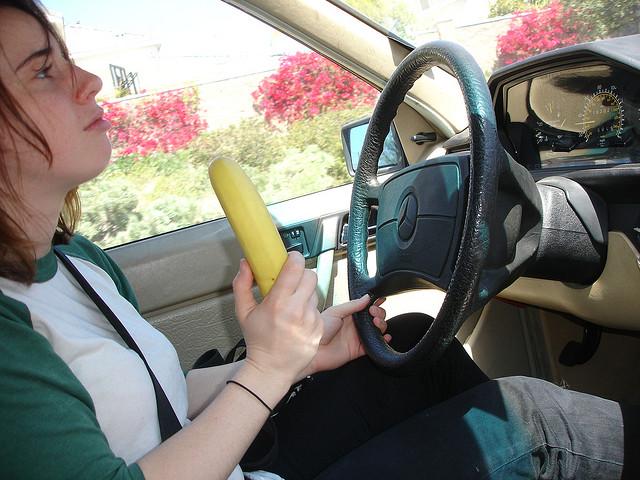Where does the person have their left hand?
Be succinct. Steering wheel. What car make is the emblem on the steering wheel?
Give a very brief answer. Mercedes. Is the person female?
Quick response, please. Yes. 